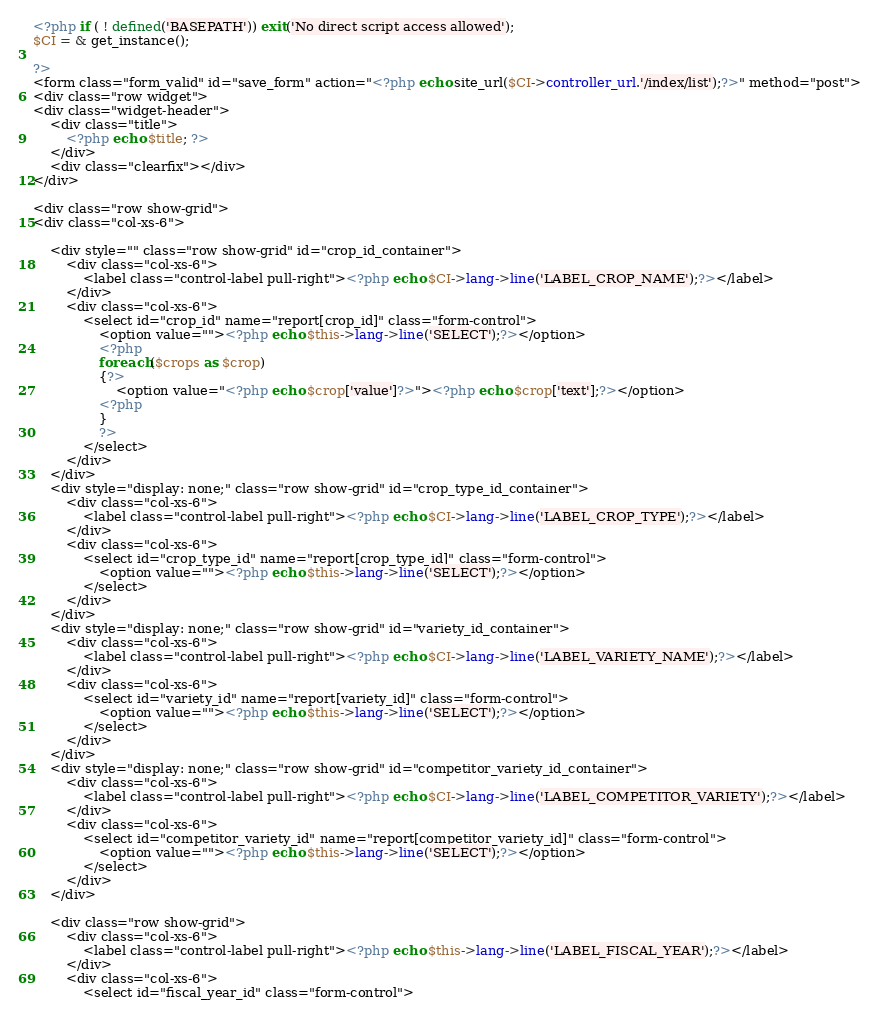<code> <loc_0><loc_0><loc_500><loc_500><_PHP_><?php if ( ! defined('BASEPATH')) exit('No direct script access allowed');
$CI = & get_instance();

?>
<form class="form_valid" id="save_form" action="<?php echo site_url($CI->controller_url.'/index/list');?>" method="post">
<div class="row widget">
<div class="widget-header">
    <div class="title">
        <?php echo $title; ?>
    </div>
    <div class="clearfix"></div>
</div>

<div class="row show-grid">
<div class="col-xs-6">

    <div style="" class="row show-grid" id="crop_id_container">
        <div class="col-xs-6">
            <label class="control-label pull-right"><?php echo $CI->lang->line('LABEL_CROP_NAME');?></label>
        </div>
        <div class="col-xs-6">
            <select id="crop_id" name="report[crop_id]" class="form-control">
                <option value=""><?php echo $this->lang->line('SELECT');?></option>
                <?php
                foreach($crops as $crop)
                {?>
                    <option value="<?php echo $crop['value']?>"><?php echo $crop['text'];?></option>
                <?php
                }
                ?>
            </select>
        </div>
    </div>
    <div style="display: none;" class="row show-grid" id="crop_type_id_container">
        <div class="col-xs-6">
            <label class="control-label pull-right"><?php echo $CI->lang->line('LABEL_CROP_TYPE');?></label>
        </div>
        <div class="col-xs-6">
            <select id="crop_type_id" name="report[crop_type_id]" class="form-control">
                <option value=""><?php echo $this->lang->line('SELECT');?></option>
            </select>
        </div>
    </div>
    <div style="display: none;" class="row show-grid" id="variety_id_container">
        <div class="col-xs-6">
            <label class="control-label pull-right"><?php echo $CI->lang->line('LABEL_VARIETY_NAME');?></label>
        </div>
        <div class="col-xs-6">
            <select id="variety_id" name="report[variety_id]" class="form-control">
                <option value=""><?php echo $this->lang->line('SELECT');?></option>
            </select>
        </div>
    </div>
    <div style="display: none;" class="row show-grid" id="competitor_variety_id_container">
        <div class="col-xs-6">
            <label class="control-label pull-right"><?php echo $CI->lang->line('LABEL_COMPETITOR_VARIETY');?></label>
        </div>
        <div class="col-xs-6">
            <select id="competitor_variety_id" name="report[competitor_variety_id]" class="form-control">
                <option value=""><?php echo $this->lang->line('SELECT');?></option>
            </select>
        </div>
    </div>

    <div class="row show-grid">
        <div class="col-xs-6">
            <label class="control-label pull-right"><?php echo $this->lang->line('LABEL_FISCAL_YEAR');?></label>
        </div>
        <div class="col-xs-6">
            <select id="fiscal_year_id" class="form-control"></code> 